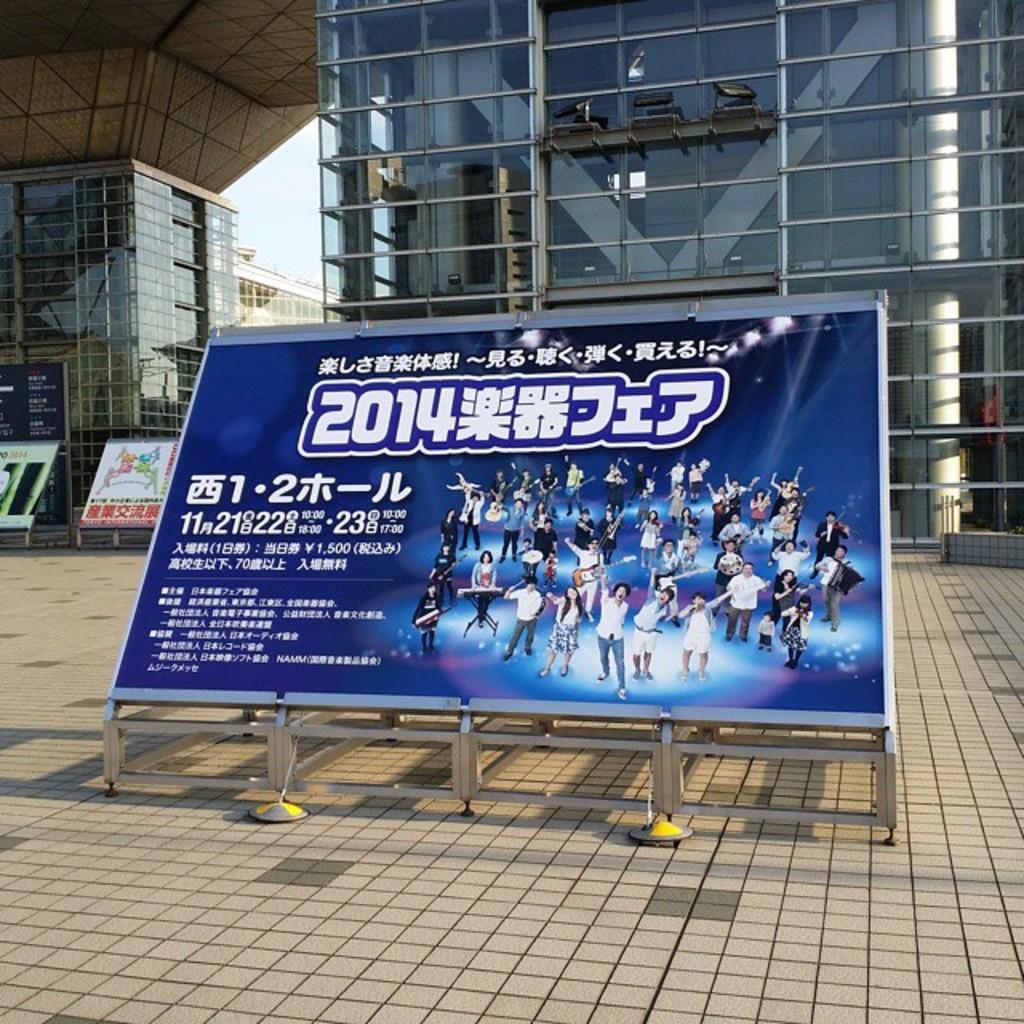What year is listed on the poster?
Give a very brief answer. 2014. 